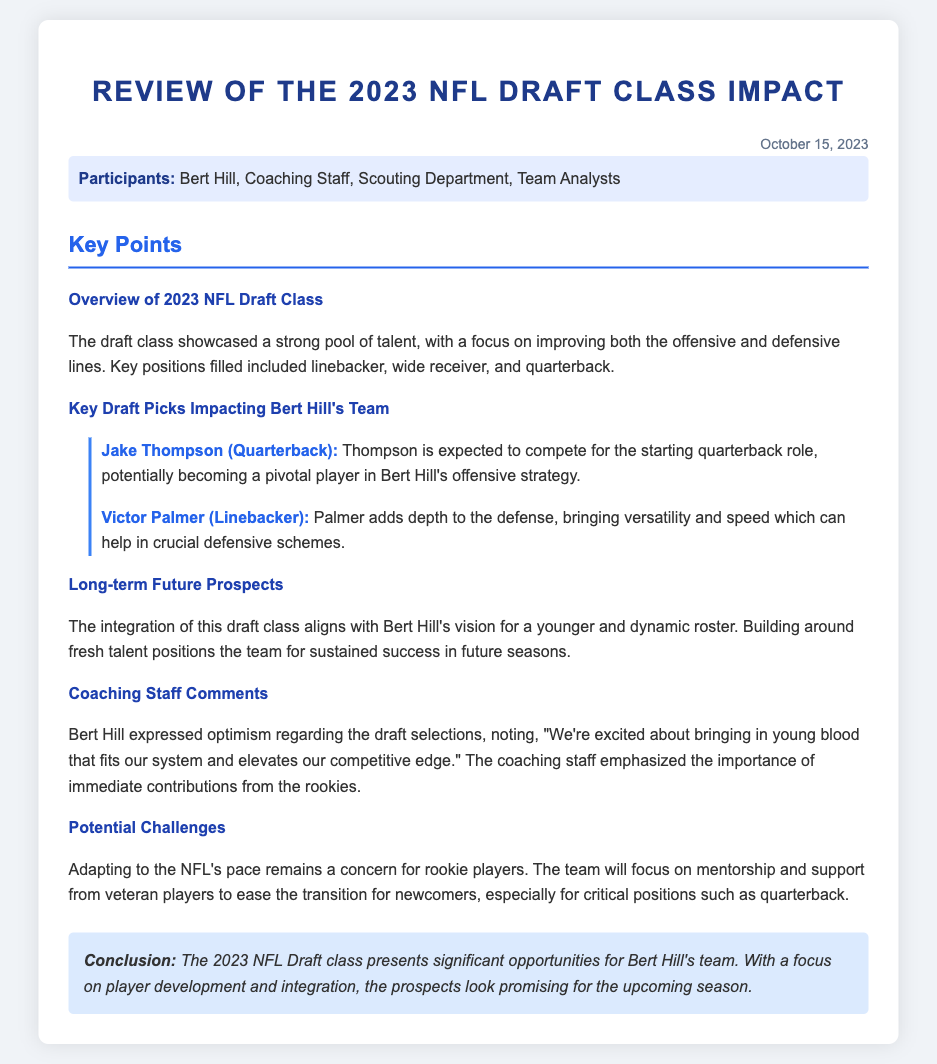What date was the meeting held? The date is mentioned at the top of the document as October 15, 2023.
Answer: October 15, 2023 Who is expected to compete for the starting quarterback role? The document lists Jake Thompson as the expected competitor for the starting quarterback role.
Answer: Jake Thompson What position does Victor Palmer play? According to the key points, Victor Palmer is identified as a linebacker.
Answer: Linebacker What is a significant focus of the 2023 NFL Draft class? The overview states that there is a strong focus on improving the offensive and defensive lines.
Answer: Offensive and defensive lines What did Bert Hill say about the draft selections? The document includes Bert Hill saying, "We're excited about bringing in young blood that fits our system and elevates our competitive edge."
Answer: "We're excited about bringing in young blood that fits our system and elevates our competitive edge." What potential challenge is highlighted for rookies? The document mentions that adapting to the NFL's pace remains a concern for rookie players.
Answer: Adapting to the NFL's pace How does the draft class align with Bert Hill's vision? It is noted that integrating the draft class aligns with Bert Hill's vision for a younger and dynamic roster.
Answer: Younger and dynamic roster What is the conclusion about the 2023 NFL Draft class? The conclusion highlights that the draft class presents significant opportunities for Bert Hill's team.
Answer: Significant opportunities for Bert Hill's team 